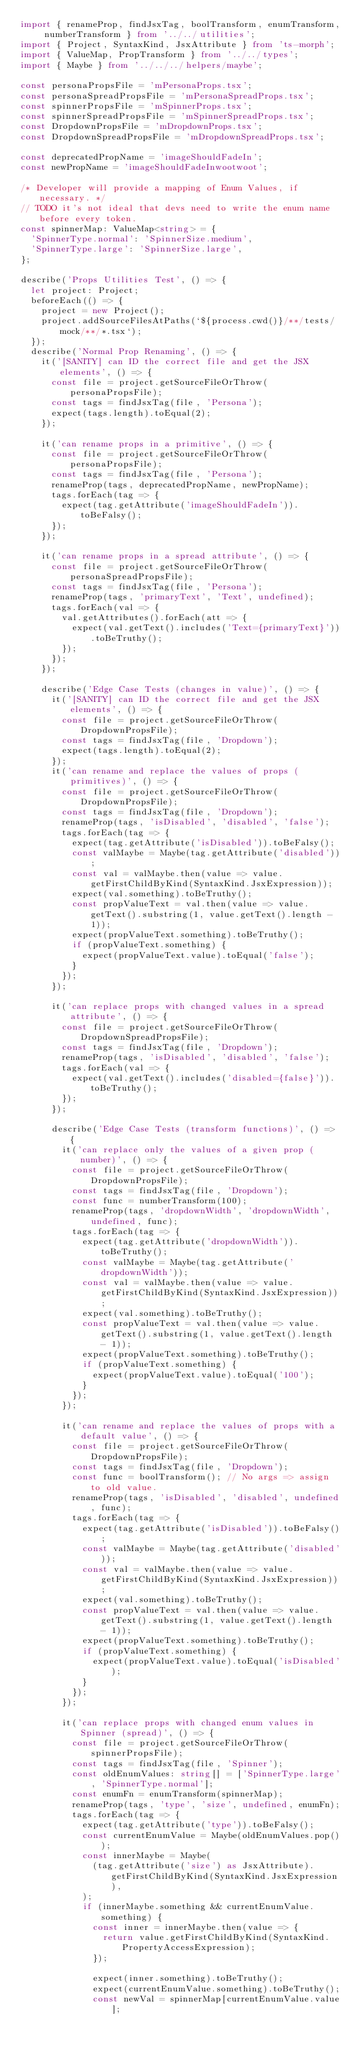Convert code to text. <code><loc_0><loc_0><loc_500><loc_500><_TypeScript_>import { renameProp, findJsxTag, boolTransform, enumTransform, numberTransform } from '../../utilities';
import { Project, SyntaxKind, JsxAttribute } from 'ts-morph';
import { ValueMap, PropTransform } from '../../types';
import { Maybe } from '../../../helpers/maybe';

const personaPropsFile = 'mPersonaProps.tsx';
const personaSpreadPropsFile = 'mPersonaSpreadProps.tsx';
const spinnerPropsFile = 'mSpinnerProps.tsx';
const spinnerSpreadPropsFile = 'mSpinnerSpreadProps.tsx';
const DropdownPropsFile = 'mDropdownProps.tsx';
const DropdownSpreadPropsFile = 'mDropdownSpreadProps.tsx';

const deprecatedPropName = 'imageShouldFadeIn';
const newPropName = 'imageShouldFadeInwootwoot';

/* Developer will provide a mapping of Enum Values, if necessary. */
// TODO it's not ideal that devs need to write the enum name before every token.
const spinnerMap: ValueMap<string> = {
  'SpinnerType.normal': 'SpinnerSize.medium',
  'SpinnerType.large': 'SpinnerSize.large',
};

describe('Props Utilities Test', () => {
  let project: Project;
  beforeEach(() => {
    project = new Project();
    project.addSourceFilesAtPaths(`${process.cwd()}/**/tests/mock/**/*.tsx`);
  });
  describe('Normal Prop Renaming', () => {
    it('[SANITY] can ID the correct file and get the JSX elements', () => {
      const file = project.getSourceFileOrThrow(personaPropsFile);
      const tags = findJsxTag(file, 'Persona');
      expect(tags.length).toEqual(2);
    });

    it('can rename props in a primitive', () => {
      const file = project.getSourceFileOrThrow(personaPropsFile);
      const tags = findJsxTag(file, 'Persona');
      renameProp(tags, deprecatedPropName, newPropName);
      tags.forEach(tag => {
        expect(tag.getAttribute('imageShouldFadeIn')).toBeFalsy();
      });
    });

    it('can rename props in a spread attribute', () => {
      const file = project.getSourceFileOrThrow(personaSpreadPropsFile);
      const tags = findJsxTag(file, 'Persona');
      renameProp(tags, 'primaryText', 'Text', undefined);
      tags.forEach(val => {
        val.getAttributes().forEach(att => {
          expect(val.getText().includes('Text={primaryText}')).toBeTruthy();
        });
      });
    });

    describe('Edge Case Tests (changes in value)', () => {
      it('[SANITY] can ID the correct file and get the JSX elements', () => {
        const file = project.getSourceFileOrThrow(DropdownPropsFile);
        const tags = findJsxTag(file, 'Dropdown');
        expect(tags.length).toEqual(2);
      });
      it('can rename and replace the values of props (primitives)', () => {
        const file = project.getSourceFileOrThrow(DropdownPropsFile);
        const tags = findJsxTag(file, 'Dropdown');
        renameProp(tags, 'isDisabled', 'disabled', 'false');
        tags.forEach(tag => {
          expect(tag.getAttribute('isDisabled')).toBeFalsy();
          const valMaybe = Maybe(tag.getAttribute('disabled'));
          const val = valMaybe.then(value => value.getFirstChildByKind(SyntaxKind.JsxExpression));
          expect(val.something).toBeTruthy();
          const propValueText = val.then(value => value.getText().substring(1, value.getText().length - 1));
          expect(propValueText.something).toBeTruthy();
          if (propValueText.something) {
            expect(propValueText.value).toEqual('false');
          }
        });
      });

      it('can replace props with changed values in a spread attribute', () => {
        const file = project.getSourceFileOrThrow(DropdownSpreadPropsFile);
        const tags = findJsxTag(file, 'Dropdown');
        renameProp(tags, 'isDisabled', 'disabled', 'false');
        tags.forEach(val => {
          expect(val.getText().includes('disabled={false}')).toBeTruthy();
        });
      });

      describe('Edge Case Tests (transform functions)', () => {
        it('can replace only the values of a given prop (number)', () => {
          const file = project.getSourceFileOrThrow(DropdownPropsFile);
          const tags = findJsxTag(file, 'Dropdown');
          const func = numberTransform(100);
          renameProp(tags, 'dropdownWidth', 'dropdownWidth', undefined, func);
          tags.forEach(tag => {
            expect(tag.getAttribute('dropdownWidth')).toBeTruthy();
            const valMaybe = Maybe(tag.getAttribute('dropdownWidth'));
            const val = valMaybe.then(value => value.getFirstChildByKind(SyntaxKind.JsxExpression));
            expect(val.something).toBeTruthy();
            const propValueText = val.then(value => value.getText().substring(1, value.getText().length - 1));
            expect(propValueText.something).toBeTruthy();
            if (propValueText.something) {
              expect(propValueText.value).toEqual('100');
            }
          });
        });

        it('can rename and replace the values of props with a default value', () => {
          const file = project.getSourceFileOrThrow(DropdownPropsFile);
          const tags = findJsxTag(file, 'Dropdown');
          const func = boolTransform(); // No args => assign to old value.
          renameProp(tags, 'isDisabled', 'disabled', undefined, func);
          tags.forEach(tag => {
            expect(tag.getAttribute('isDisabled')).toBeFalsy();
            const valMaybe = Maybe(tag.getAttribute('disabled'));
            const val = valMaybe.then(value => value.getFirstChildByKind(SyntaxKind.JsxExpression));
            expect(val.something).toBeTruthy();
            const propValueText = val.then(value => value.getText().substring(1, value.getText().length - 1));
            expect(propValueText.something).toBeTruthy();
            if (propValueText.something) {
              expect(propValueText.value).toEqual('isDisabled');
            }
          });
        });

        it('can replace props with changed enum values in Spinner (spread)', () => {
          const file = project.getSourceFileOrThrow(spinnerPropsFile);
          const tags = findJsxTag(file, 'Spinner');
          const oldEnumValues: string[] = ['SpinnerType.large', 'SpinnerType.normal'];
          const enumFn = enumTransform(spinnerMap);
          renameProp(tags, 'type', 'size', undefined, enumFn);
          tags.forEach(tag => {
            expect(tag.getAttribute('type')).toBeFalsy();
            const currentEnumValue = Maybe(oldEnumValues.pop());
            const innerMaybe = Maybe(
              (tag.getAttribute('size') as JsxAttribute).getFirstChildByKind(SyntaxKind.JsxExpression),
            );
            if (innerMaybe.something && currentEnumValue.something) {
              const inner = innerMaybe.then(value => {
                return value.getFirstChildByKind(SyntaxKind.PropertyAccessExpression);
              });

              expect(inner.something).toBeTruthy();
              expect(currentEnumValue.something).toBeTruthy();
              const newVal = spinnerMap[currentEnumValue.value];</code> 